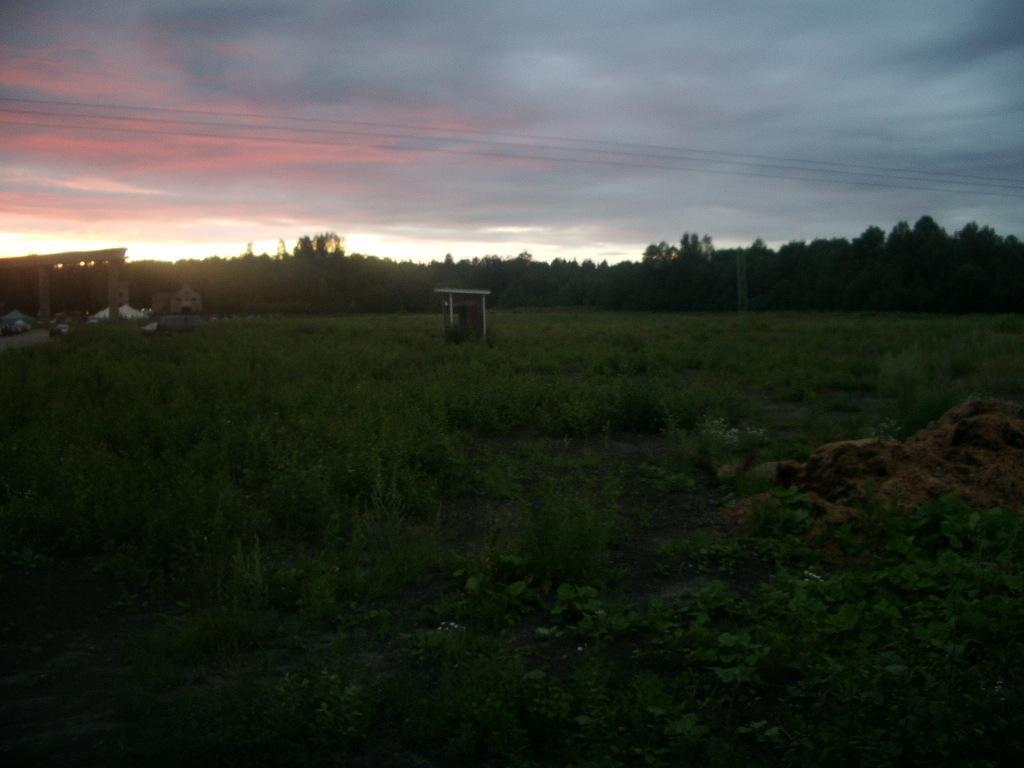Could you give a brief overview of what you see in this image? In this picture we can see grass and some plants at the bottom, in the background there are some trees, we can see the sky at the top of the picture. 